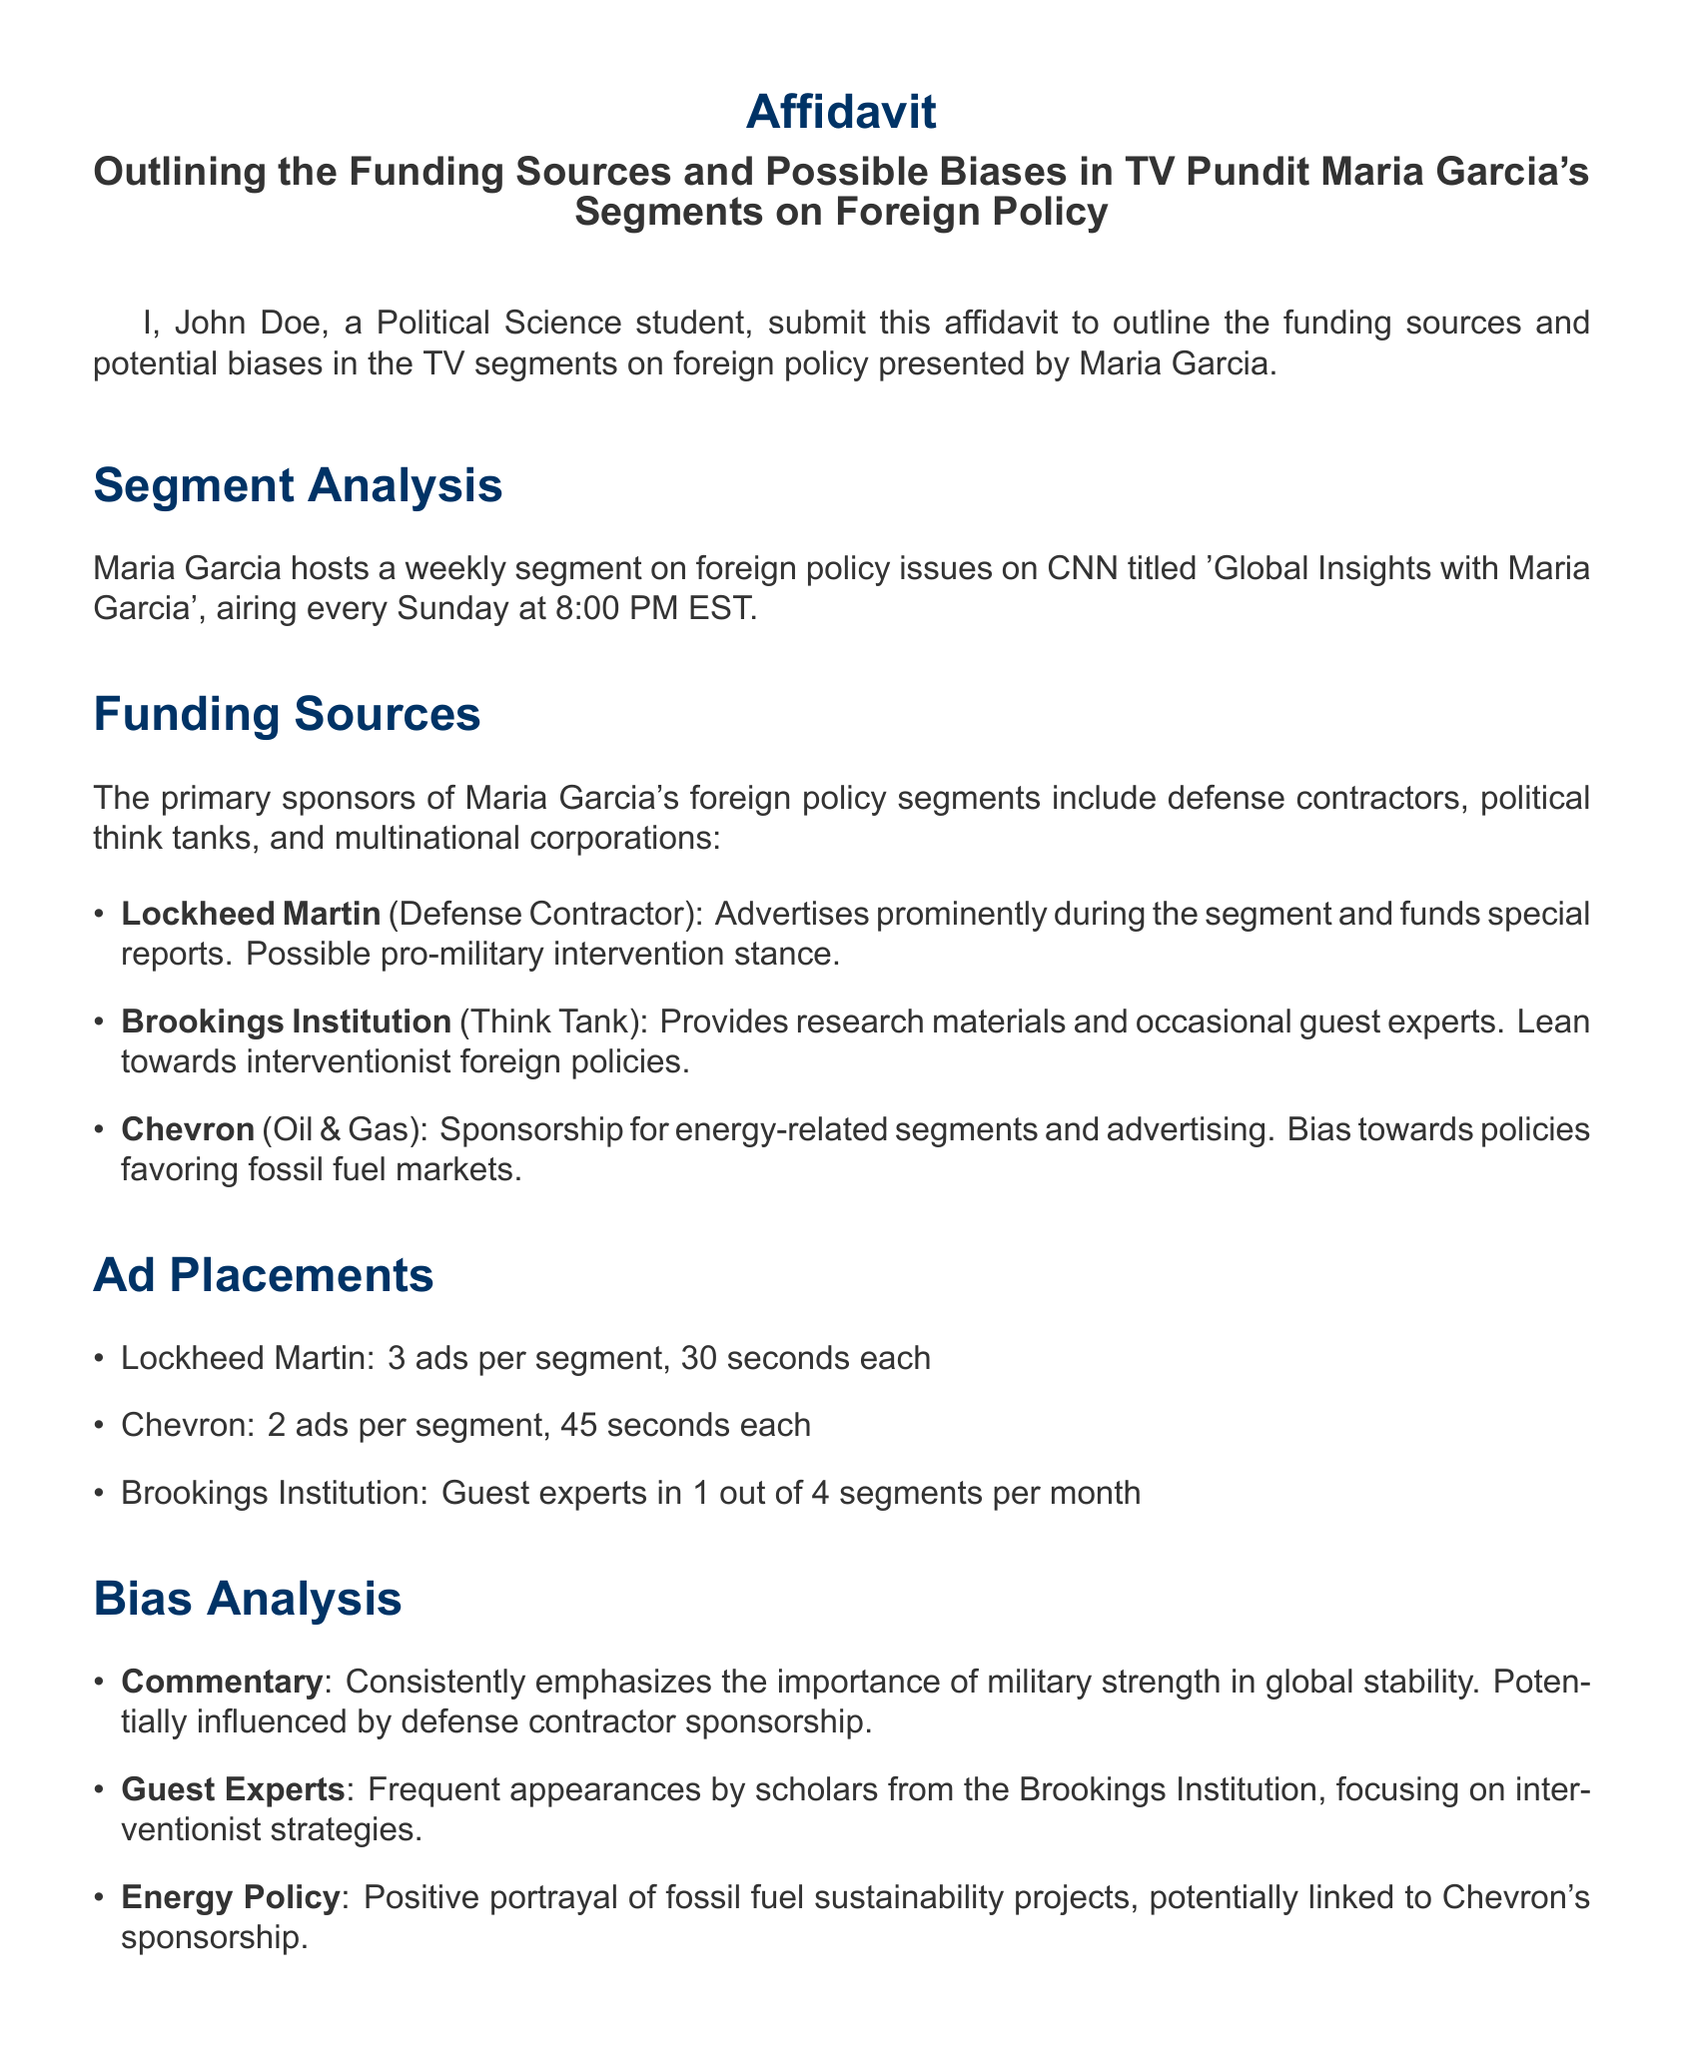What is the title of Maria Garcia's segment? The title is stated in the document as 'Global Insights with Maria Garcia'.
Answer: Global Insights with Maria Garcia How often does the segment air? The frequency of the segment is mentioned as weekly.
Answer: Weekly Which corporation sponsors energy-related segments? The document lists Chevron as the sponsor for energy-related segments.
Answer: Chevron How many ads does Lockheed Martin run per segment? The number of ads is specified in the document, stating 3 ads per segment.
Answer: 3 ads What is the focus of the commentary in the segments? The document indicates that the commentary emphasizes military strength in global stability.
Answer: Military strength From which think tank do guest experts frequently appear? The document mentions the Brookings Institution as the think tank contributing guest experts.
Answer: Brookings Institution What is the potential bias towards energy policy? The document notes a positive portrayal of fossil fuel sustainability projects as the potential bias.
Answer: Positive portrayal Who submitted the affidavit? The author of the affidavit is mentioned as John Doe.
Answer: John Doe What is the date of the affidavit? The document states that the affidavit was submitted on October 10, 2023.
Answer: October 10, 2023 